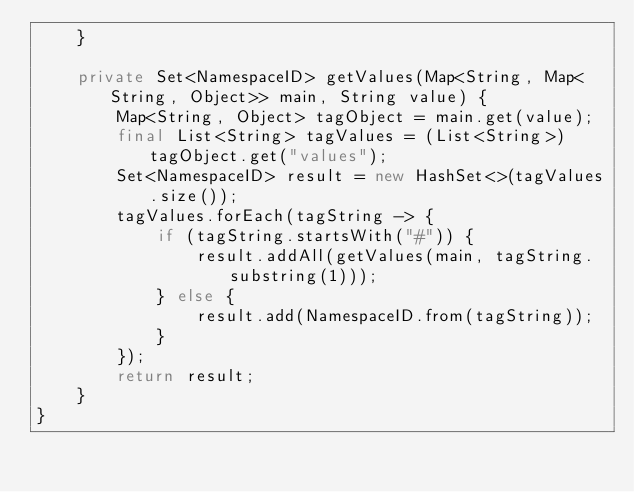<code> <loc_0><loc_0><loc_500><loc_500><_Java_>    }

    private Set<NamespaceID> getValues(Map<String, Map<String, Object>> main, String value) {
        Map<String, Object> tagObject = main.get(value);
        final List<String> tagValues = (List<String>) tagObject.get("values");
        Set<NamespaceID> result = new HashSet<>(tagValues.size());
        tagValues.forEach(tagString -> {
            if (tagString.startsWith("#")) {
                result.addAll(getValues(main, tagString.substring(1)));
            } else {
                result.add(NamespaceID.from(tagString));
            }
        });
        return result;
    }
}
</code> 